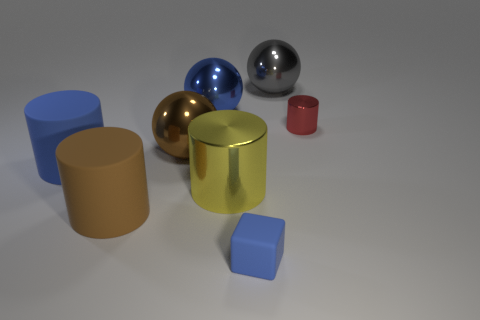What material is the big cylinder that is the same color as the small cube?
Your answer should be very brief. Rubber. What number of big cylinders are behind the blue matte thing that is left of the tiny blue rubber thing?
Your answer should be compact. 0. Does the tiny thing that is right of the small matte cube have the same color as the tiny object left of the gray metal ball?
Ensure brevity in your answer.  No. There is a yellow cylinder that is the same size as the gray metal object; what material is it?
Offer a very short reply. Metal. What is the shape of the big blue thing that is on the left side of the blue metal thing behind the metal sphere that is in front of the tiny shiny thing?
Provide a succinct answer. Cylinder. The other blue thing that is the same size as the blue metal thing is what shape?
Give a very brief answer. Cylinder. There is a large blue object that is behind the big thing that is left of the brown cylinder; what number of yellow cylinders are left of it?
Give a very brief answer. 0. Is the number of red metal cylinders that are in front of the brown rubber thing greater than the number of big things that are in front of the big yellow cylinder?
Ensure brevity in your answer.  No. What number of other large metal objects are the same shape as the large gray shiny thing?
Your answer should be very brief. 2. How many things are either big rubber objects on the left side of the large brown cylinder or cylinders to the left of the tiny blue thing?
Provide a succinct answer. 3. 